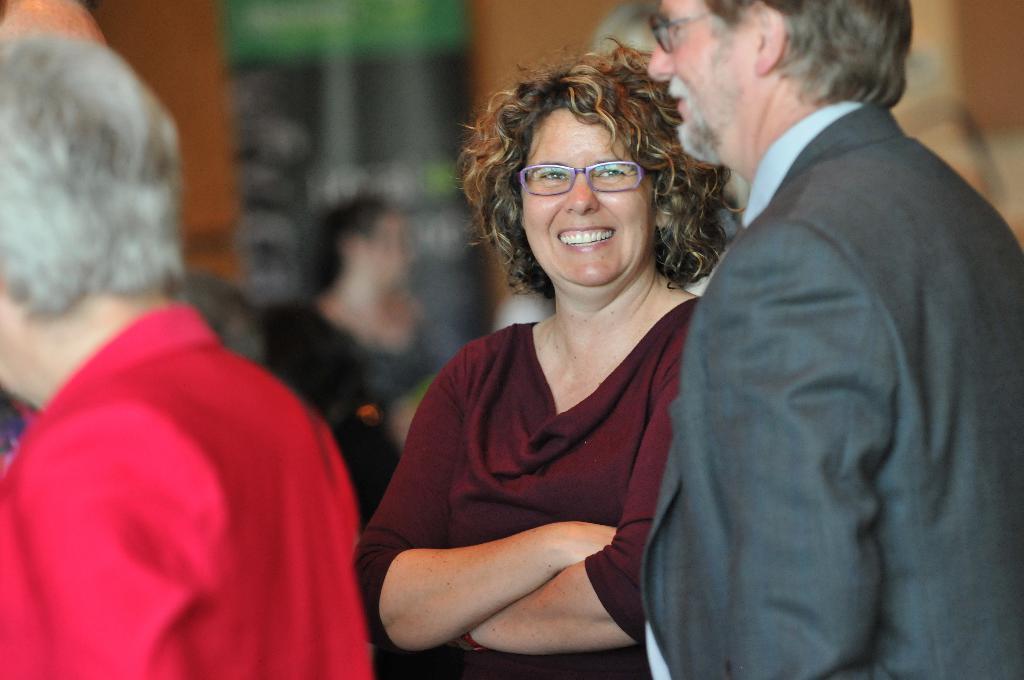Can you describe this image briefly? In the image few people are standing and smiling. Background of the image is blur. 